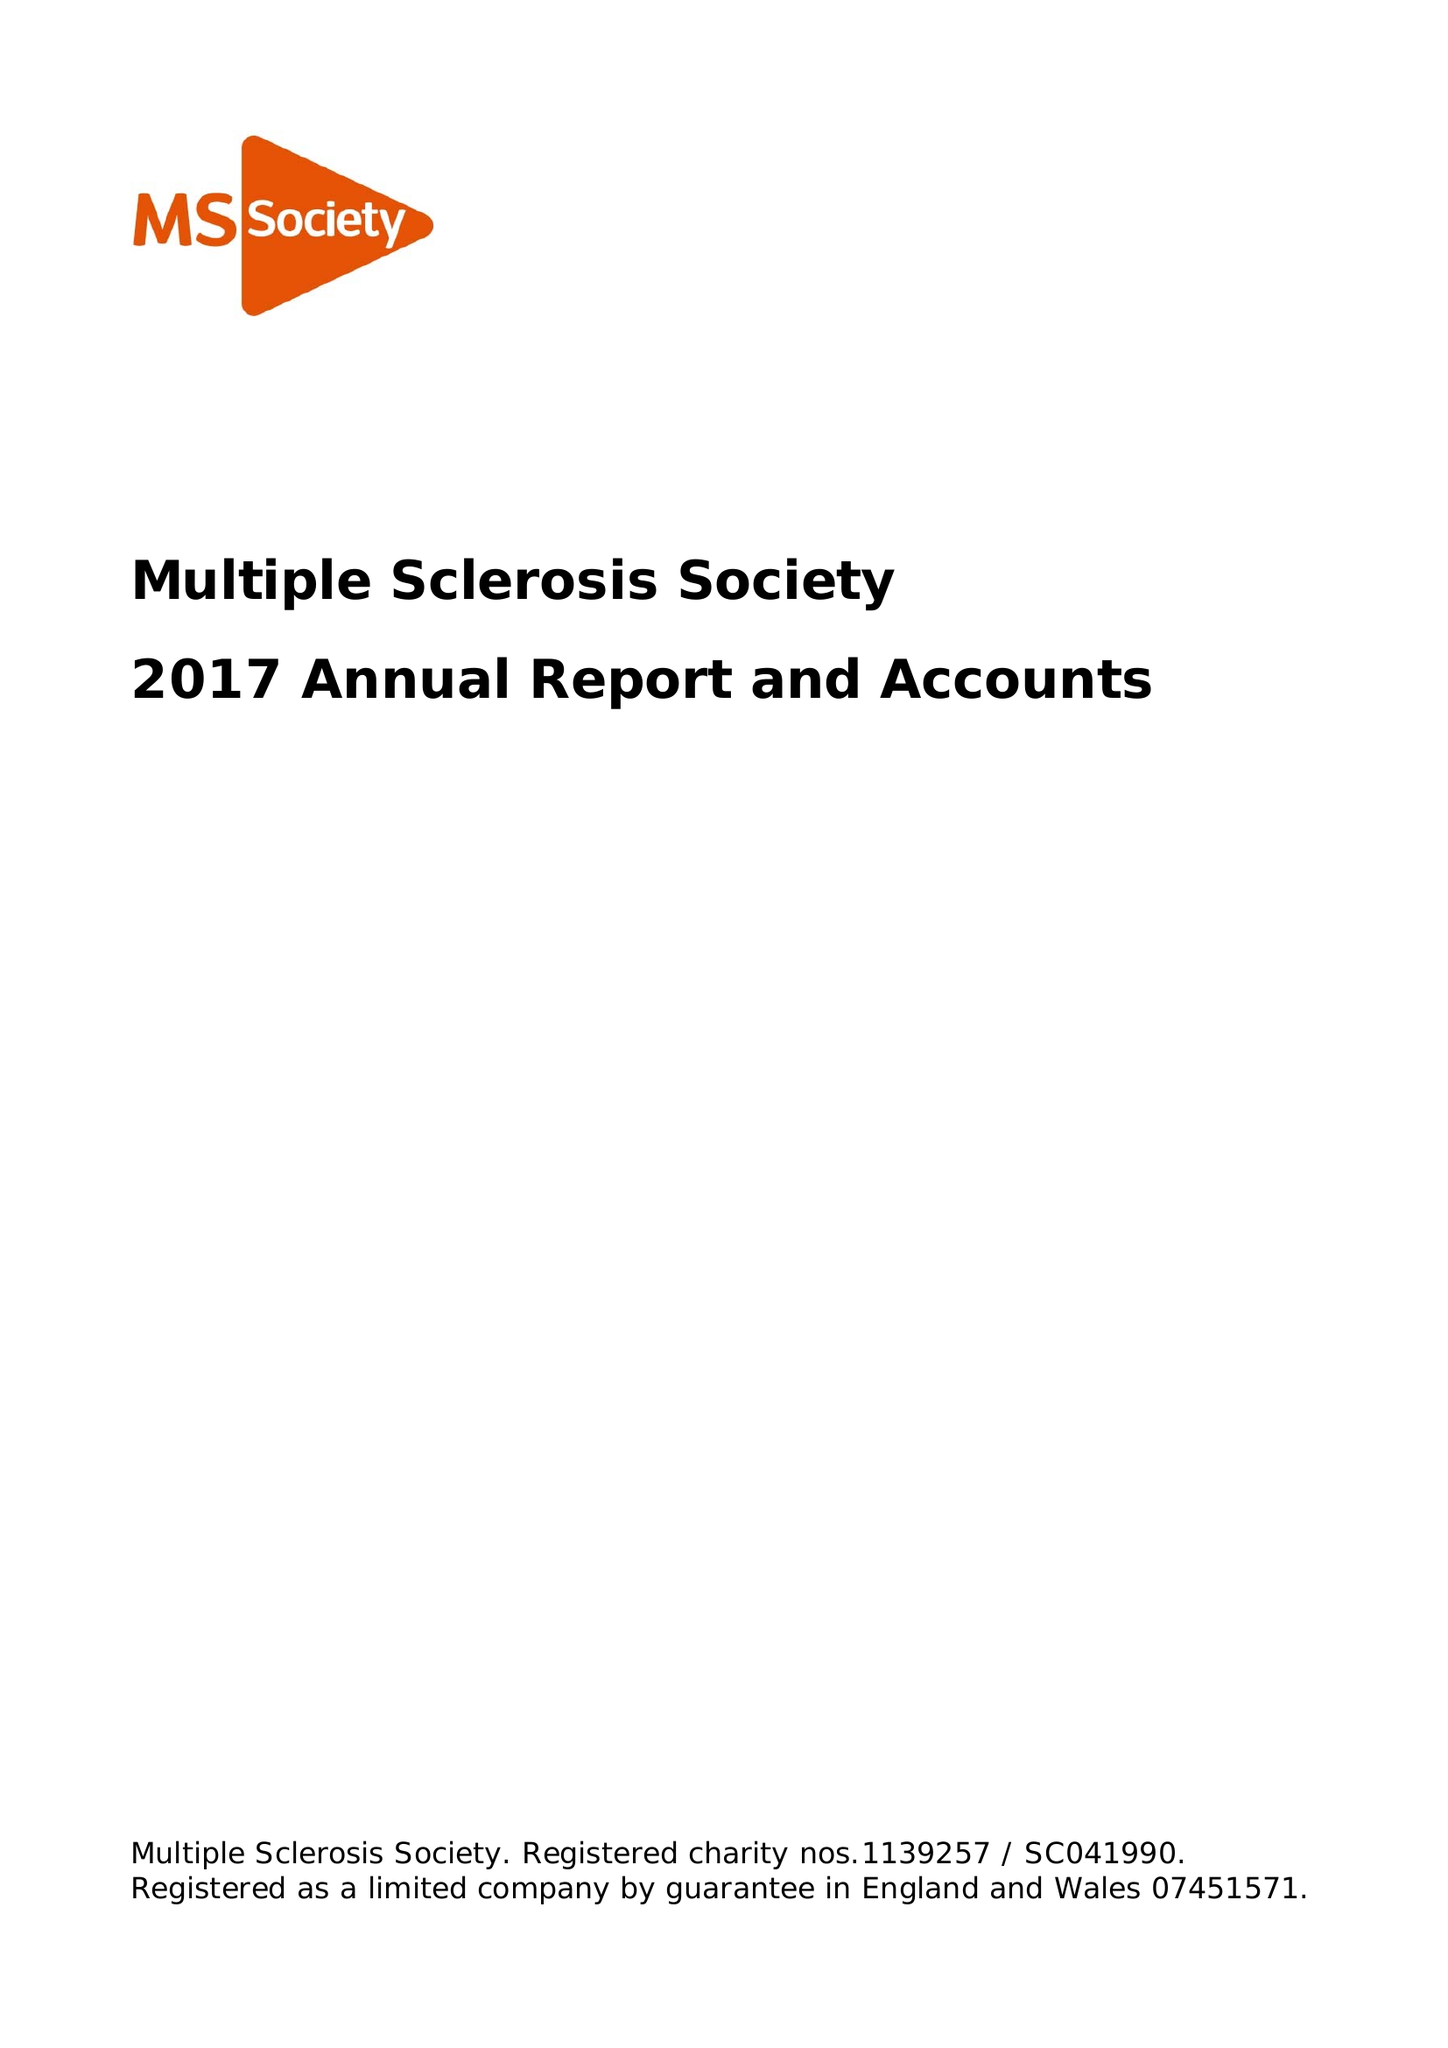What is the value for the address__street_line?
Answer the question using a single word or phrase. 372 EDGWARE ROAD 